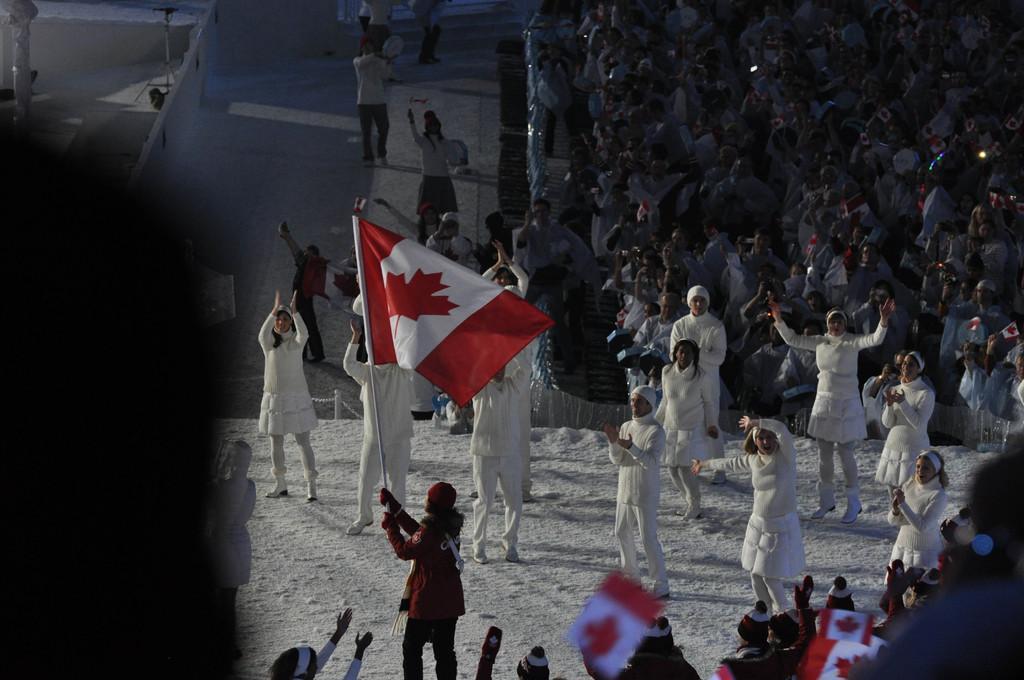Can you describe this image briefly? This picture describes about group of people, few are standing and few are walking, and we can see few people are holding flags in their hands. 